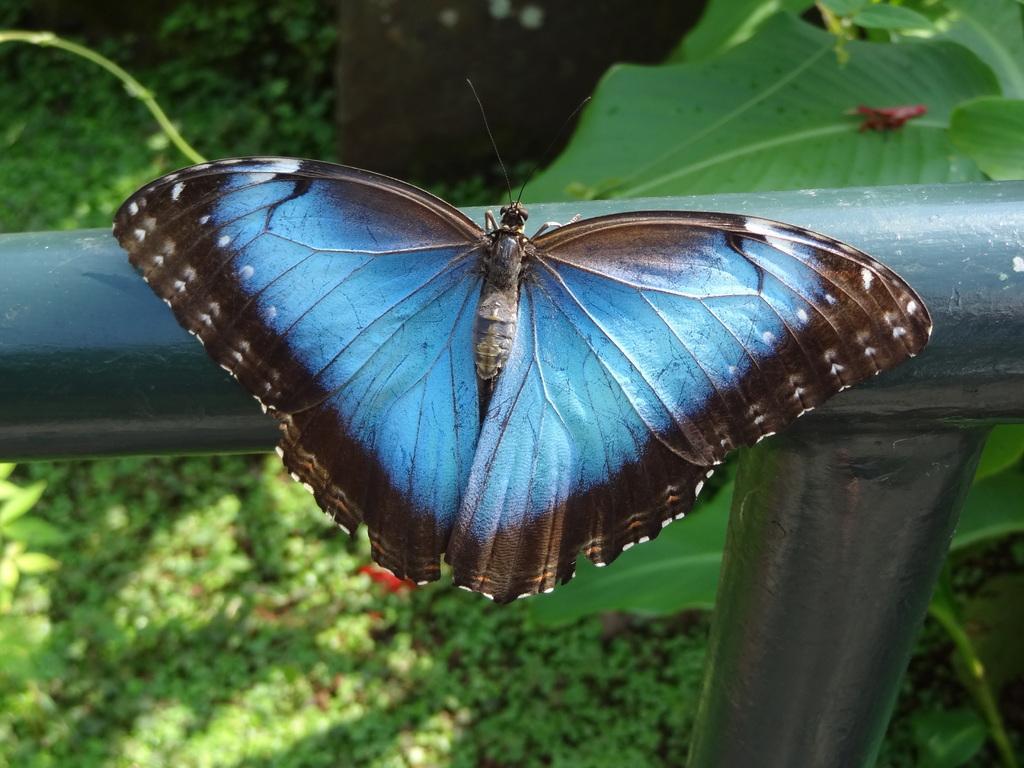In one or two sentences, can you explain what this image depicts? In this image there is a butterfly on the metal fence. Behind there is a plant. Background there are few plants on the land. 